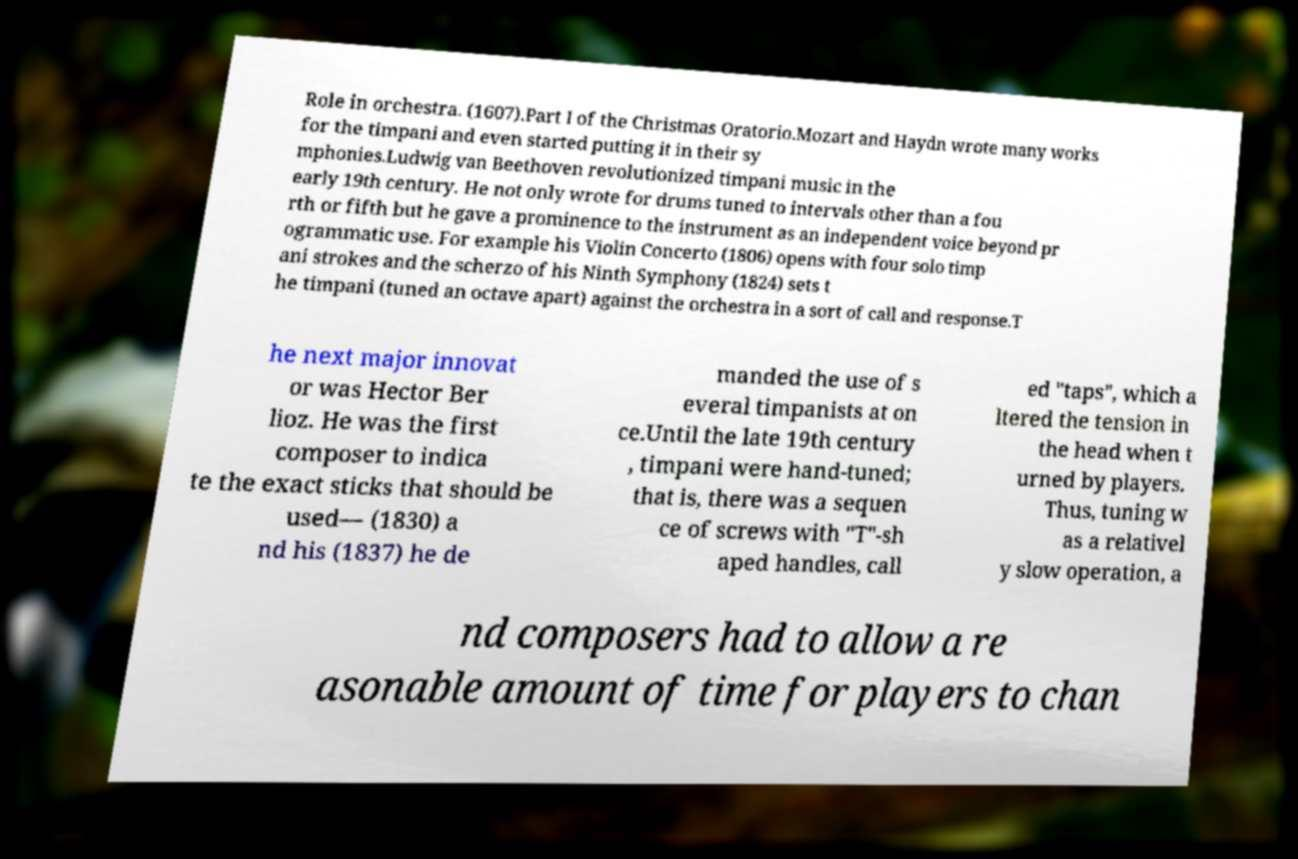Please read and relay the text visible in this image. What does it say? Role in orchestra. (1607).Part I of the Christmas Oratorio.Mozart and Haydn wrote many works for the timpani and even started putting it in their sy mphonies.Ludwig van Beethoven revolutionized timpani music in the early 19th century. He not only wrote for drums tuned to intervals other than a fou rth or fifth but he gave a prominence to the instrument as an independent voice beyond pr ogrammatic use. For example his Violin Concerto (1806) opens with four solo timp ani strokes and the scherzo of his Ninth Symphony (1824) sets t he timpani (tuned an octave apart) against the orchestra in a sort of call and response.T he next major innovat or was Hector Ber lioz. He was the first composer to indica te the exact sticks that should be used— (1830) a nd his (1837) he de manded the use of s everal timpanists at on ce.Until the late 19th century , timpani were hand-tuned; that is, there was a sequen ce of screws with "T"-sh aped handles, call ed "taps", which a ltered the tension in the head when t urned by players. Thus, tuning w as a relativel y slow operation, a nd composers had to allow a re asonable amount of time for players to chan 